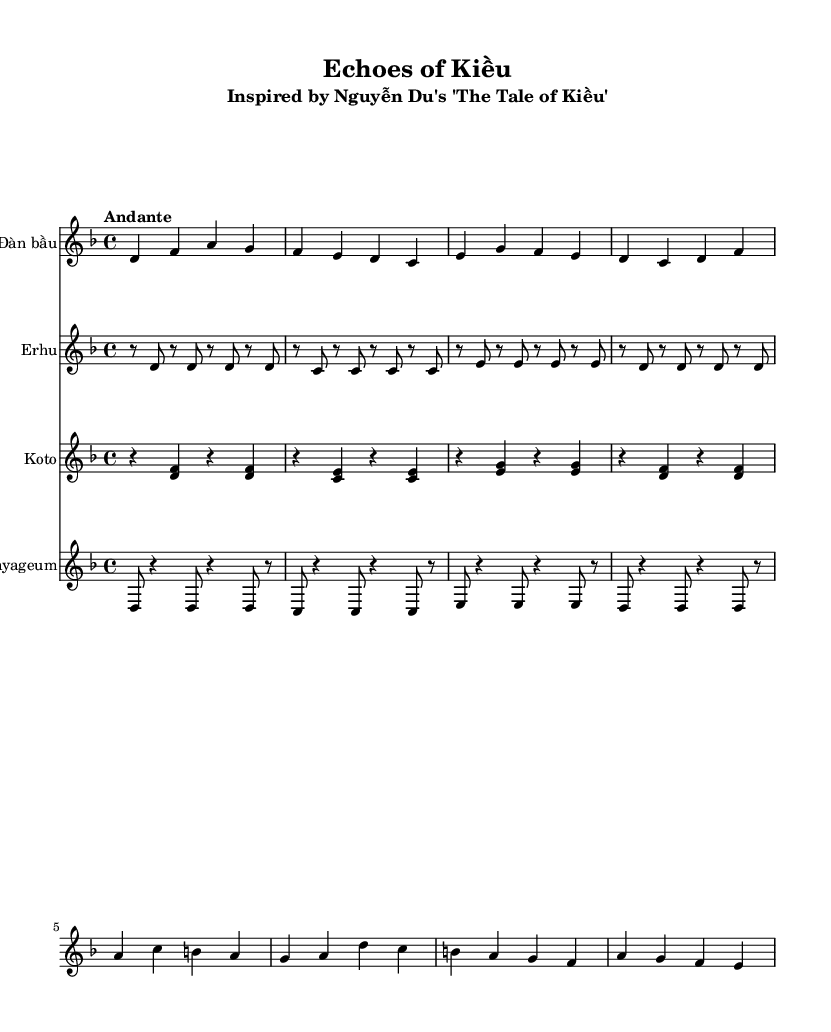What is the key signature of this music? The key signature is indicated at the beginning of the music, showing two flats which signifies D minor.
Answer: D minor What is the time signature of this performance? The time signature is represented as 4/4 at the beginning of the piece, indicating four beats per measure.
Answer: 4/4 What is the tempo marking for this piece? The tempo marking is found above the staff, describing the speed as "Andante," which suggests a moderately slow pace.
Answer: Andante How many different instruments are featured in this score? By counting the different staves, there are four instruments: Đàn bầu, Erhu, Koto, and Gayageum listed.
Answer: Four Which instrument has the highest pitch in this ensemble? The notes for Đàn bầu are typically higher than those for the Erhu, Koto, and Gayageum, indicating it has the highest pitch among the instruments.
Answer: Đàn bầu What is the rhythmic pattern of the Erhu in the first measure? The rhythmic pattern in the first measure consists of alternating eighth notes, starting and ending with rest notes.
Answer: Rest and eighth notes Which instrument plays a consistent rhythm throughout its part? The Gayageum part shows a repeated rhythmic pattern without any significant changes in the rhythm.
Answer: Gayageum 